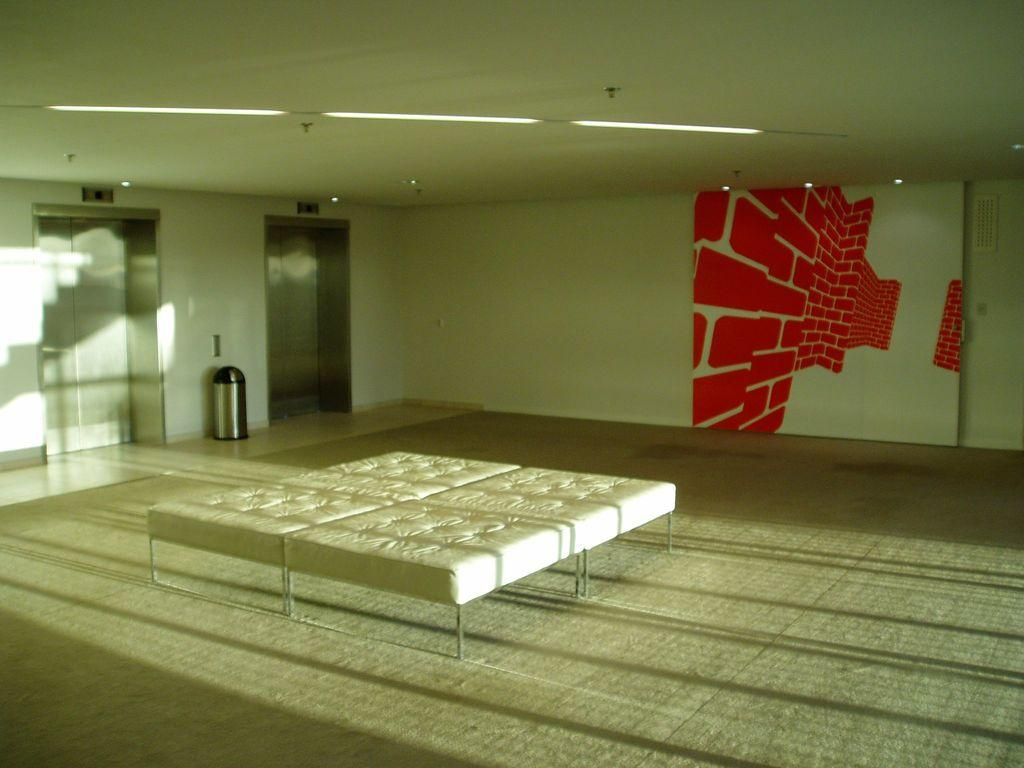What is placed on the floor in the image? There is a mattress on the floor in the image. What type of decoration can be seen on the wall in the image? There is wall art in the image. Where is the image taken? The image shows a lift lobby. What is used for waste disposal in the image? There is a trash can in the image. What type of lighting is visible in the image? Ceiling lights are visible in the image. What type of waves can be seen crashing on the shore in the image? There are no waves or shore visible in the image; it shows a lift lobby with a mattress, wall art, a trash can, and ceiling lights. 